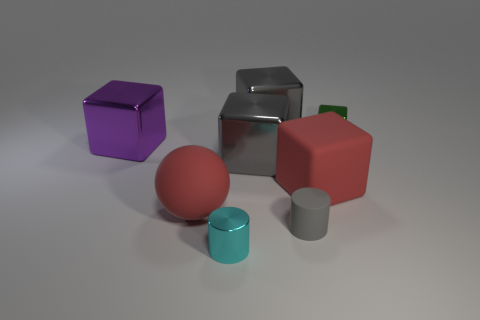Subtract all purple blocks. How many blocks are left? 4 Subtract all small cubes. How many cubes are left? 4 Subtract all cyan cubes. Subtract all blue cylinders. How many cubes are left? 5 Add 2 red things. How many objects exist? 10 Subtract all cylinders. How many objects are left? 6 Add 3 big blue things. How many big blue things exist? 3 Subtract 0 blue balls. How many objects are left? 8 Subtract all red spheres. Subtract all rubber spheres. How many objects are left? 6 Add 2 tiny cyan shiny cylinders. How many tiny cyan shiny cylinders are left? 3 